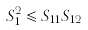Convert formula to latex. <formula><loc_0><loc_0><loc_500><loc_500>S _ { 1 } ^ { 2 } \leqslant S _ { 1 1 } S _ { 1 2 }</formula> 